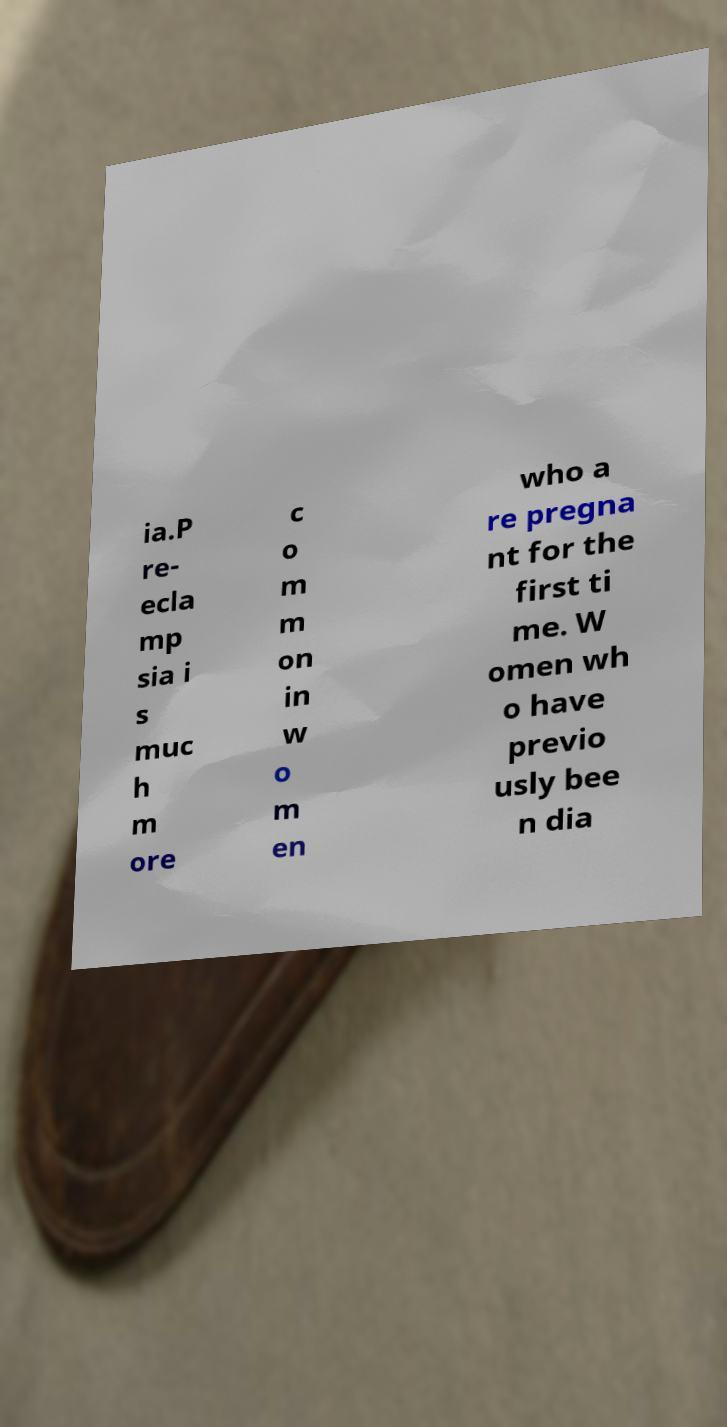I need the written content from this picture converted into text. Can you do that? ia.P re- ecla mp sia i s muc h m ore c o m m on in w o m en who a re pregna nt for the first ti me. W omen wh o have previo usly bee n dia 